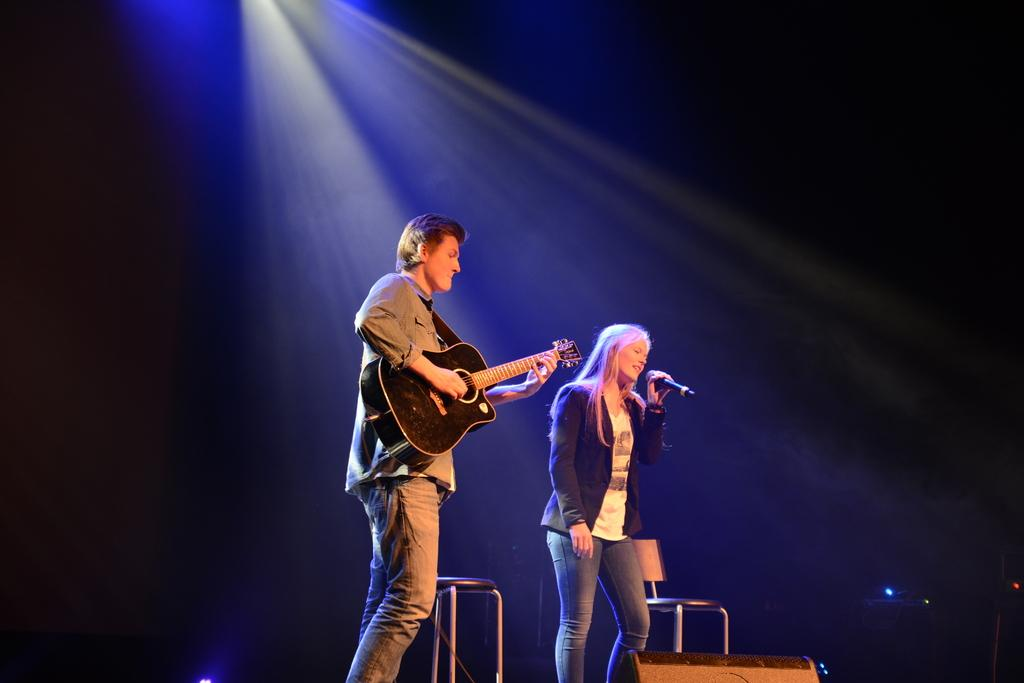What is the man in the image doing? The man is standing and playing a guitar. What is the woman in the image doing? The woman is standing and singing into a microphone. What can be seen in the background of the image? There are chairs and a focus light in the background of the image. What type of pets are visible in the image? There are no pets visible in the image. How tall are the giants in the image? There are no giants present in the image. 